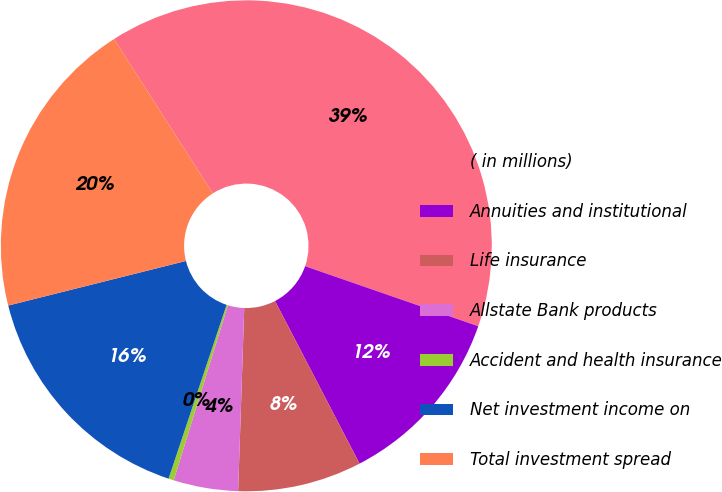Convert chart. <chart><loc_0><loc_0><loc_500><loc_500><pie_chart><fcel>( in millions)<fcel>Annuities and institutional<fcel>Life insurance<fcel>Allstate Bank products<fcel>Accident and health insurance<fcel>Net investment income on<fcel>Total investment spread<nl><fcel>39.37%<fcel>12.06%<fcel>8.16%<fcel>4.25%<fcel>0.35%<fcel>15.96%<fcel>19.86%<nl></chart> 